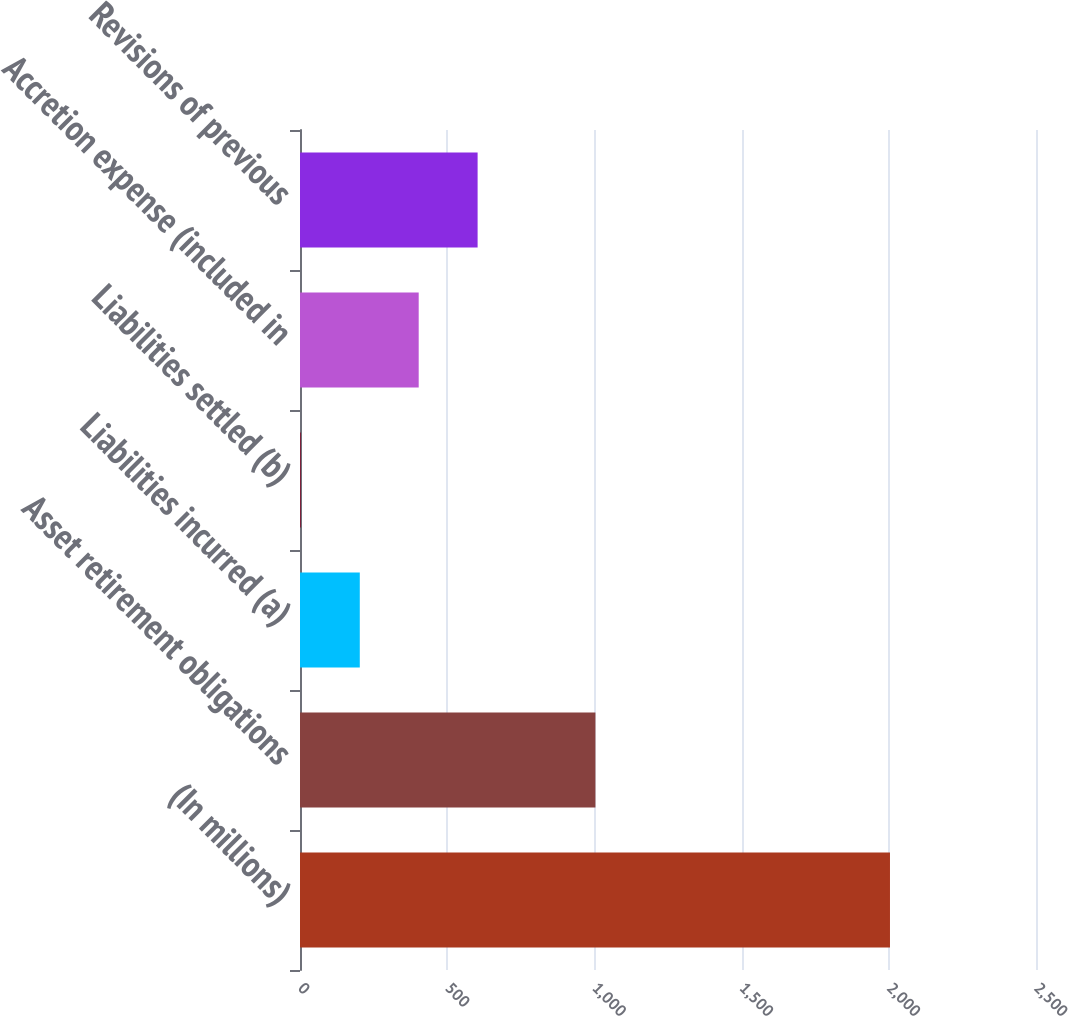Convert chart. <chart><loc_0><loc_0><loc_500><loc_500><bar_chart><fcel>(In millions)<fcel>Asset retirement obligations<fcel>Liabilities incurred (a)<fcel>Liabilities settled (b)<fcel>Accretion expense (included in<fcel>Revisions of previous<nl><fcel>2004<fcel>1003.5<fcel>203.1<fcel>3<fcel>403.2<fcel>603.3<nl></chart> 